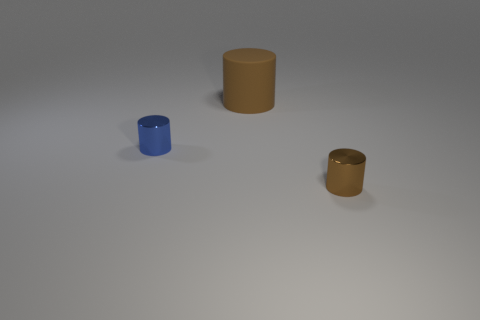Is there anything else that is made of the same material as the large brown object?
Give a very brief answer. No. What material is the cylinder that is both left of the tiny brown cylinder and in front of the big cylinder?
Offer a terse response. Metal. What is the shape of the blue thing that is made of the same material as the tiny brown object?
Your answer should be compact. Cylinder. Is there any other thing that has the same color as the big cylinder?
Offer a very short reply. Yes. Are there more things behind the matte cylinder than big cylinders?
Ensure brevity in your answer.  No. What material is the blue cylinder?
Your response must be concise. Metal. How many blue metallic cylinders are the same size as the brown matte cylinder?
Make the answer very short. 0. Are there an equal number of blue metal objects that are to the right of the small blue metallic object and big matte cylinders behind the brown matte cylinder?
Provide a succinct answer. Yes. Are the large brown cylinder and the small blue thing made of the same material?
Your response must be concise. No. Are there any big brown matte cylinders that are to the right of the brown metallic cylinder on the right side of the large cylinder?
Provide a short and direct response. No. 